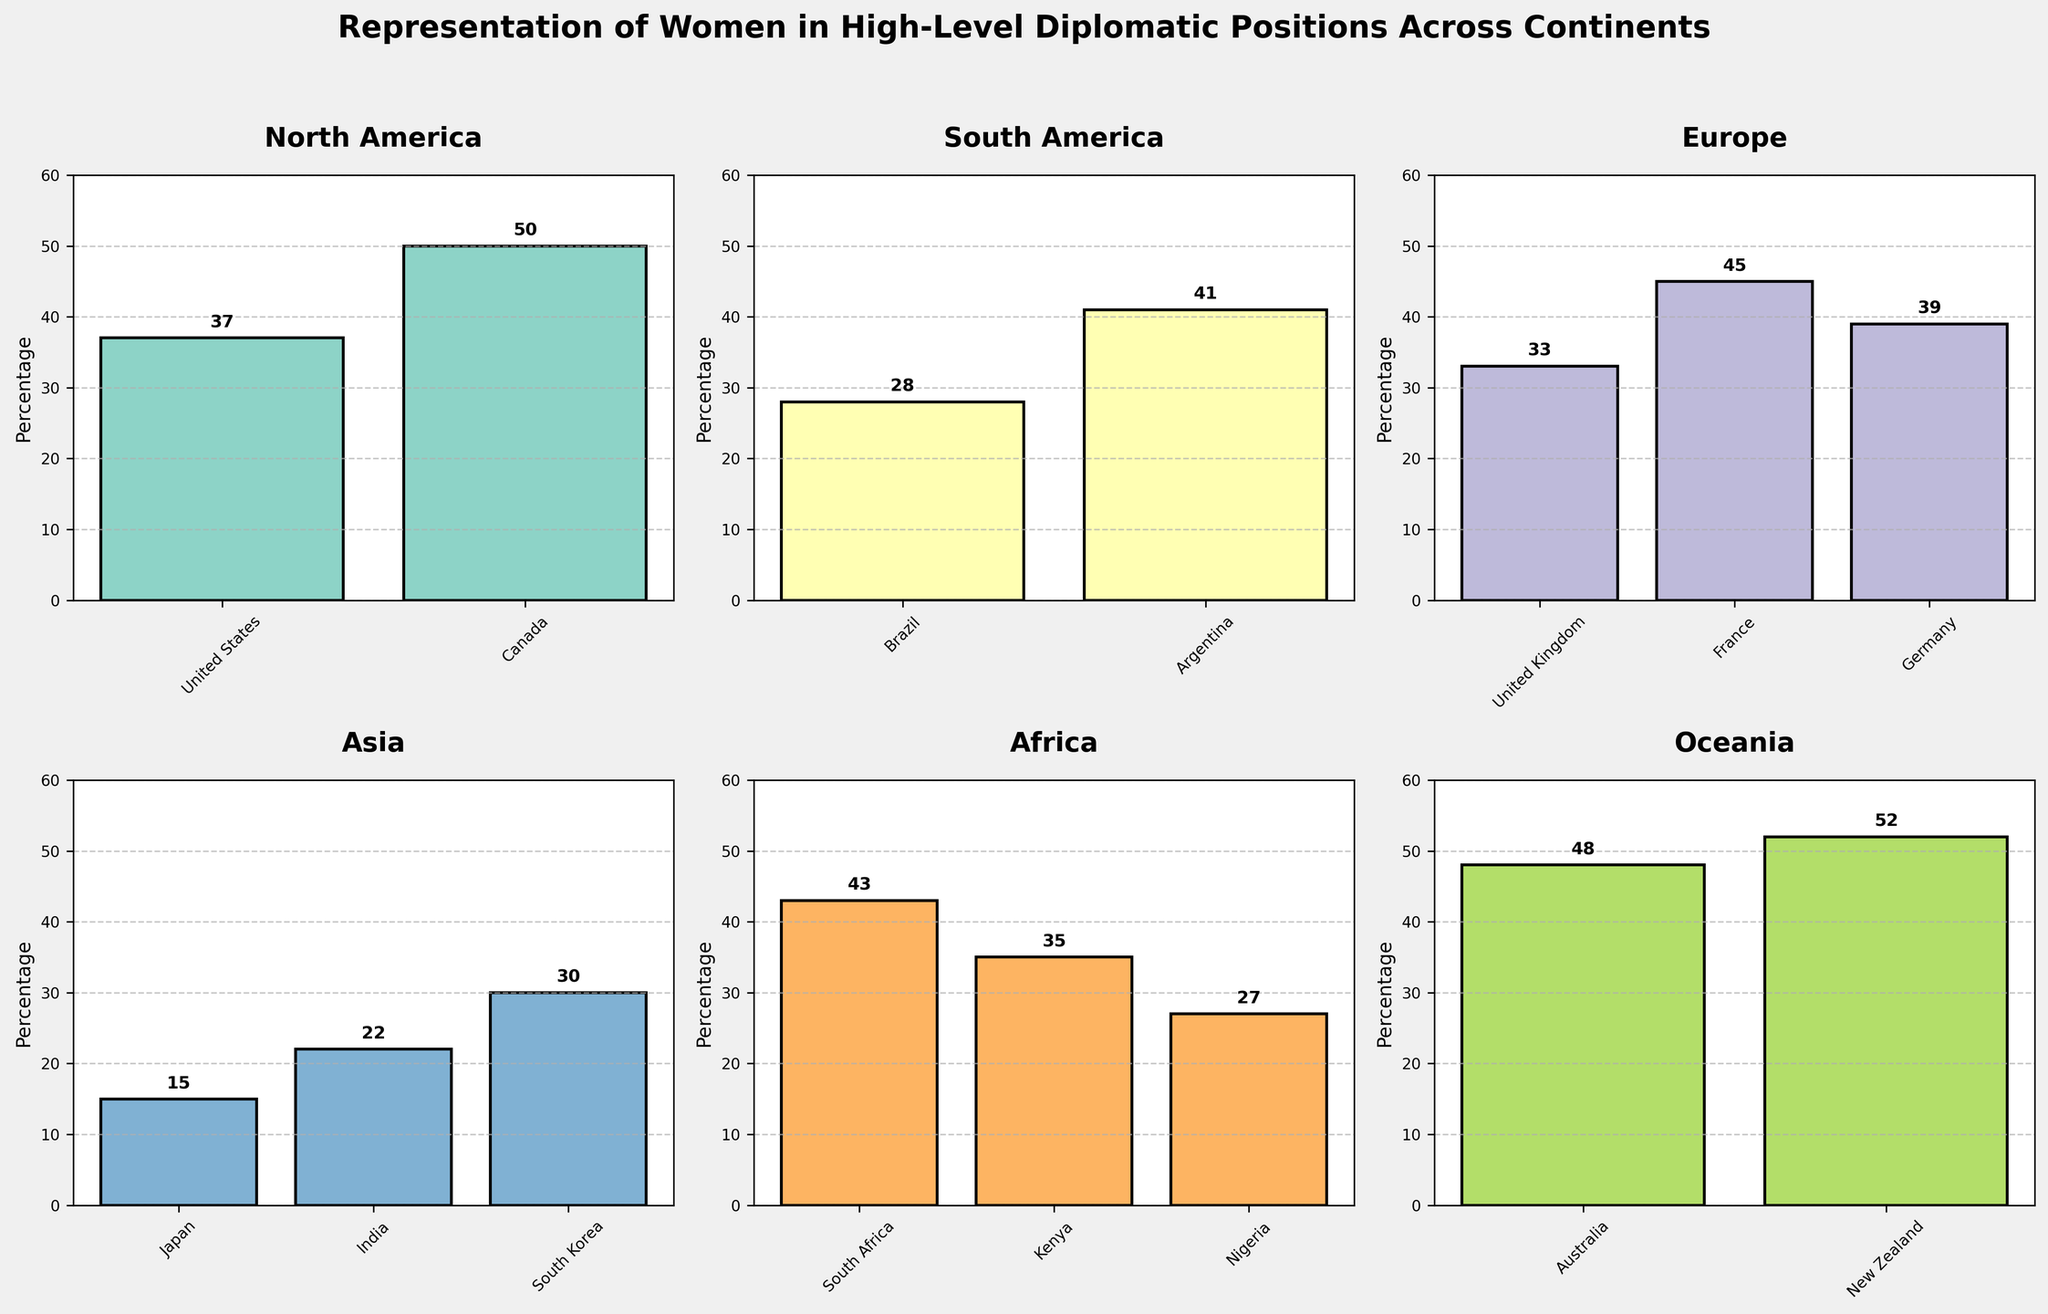What is the title of the figure? The title is displayed at the top of the figure, summarizing its content in a concise phrase.
Answer: Representation of Women in High-Level Diplomatic Positions Across Continents Which country in Oceania has the highest percentage of women in high-level diplomatic positions? By looking at the Oceania subplot, New Zealand has a bar reaching the highest value.
Answer: New Zealand What is the percentage of women in high-level diplomatic positions in Brazil? In the South America subplot, find the bar representing Brazil and read the percentage value above it.
Answer: 28% Which continent has the most countries represented in the figure? Count the number of bars in each subplot. Europe has three countries.
Answer: Europe What is the average percentage of women in high-level diplomatic positions in Asia? Add the percentages of Japan, India, and South Korea and divide by three: (15+22+30)/3.
Answer: 22.33% Is there a country in Africa with a higher percentage of women in high-level diplomatic positions than France? Compare the percentage bars of the countries in the Africa subplot with the bar for France (45%) in Europe. South Africa (43%) and Kenya (35%) are lower.
Answer: No Which continent has the lowest overall representation of women in high-level diplomatic positions? Visually compare the average bar heights across all subplots. Asia has the lowest bars on average.
Answer: Asia How much higher is the percentage of women in high-level diplomatic positions in Canada compared to Japan? Subtract Japan's percentage (15%) from Canada's percentage (50%): 50 - 15.
Answer: 35% Which country in North America has a lower percentage representation of women in high-level diplomatic positions? In the North America subplot, compare the bar heights of the United States and Canada. The United States has a lower percentage.
Answer: United States 